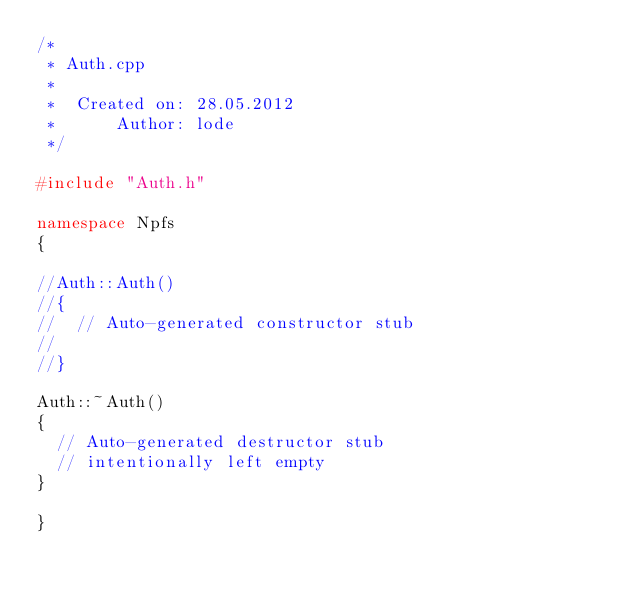Convert code to text. <code><loc_0><loc_0><loc_500><loc_500><_C++_>/*
 * Auth.cpp
 *
 *  Created on: 28.05.2012
 *      Author: lode
 */

#include "Auth.h"

namespace Npfs
{

//Auth::Auth()
//{
//  // Auto-generated constructor stub
//
//}

Auth::~Auth()
{
  // Auto-generated destructor stub
  // intentionally left empty
}

}
</code> 